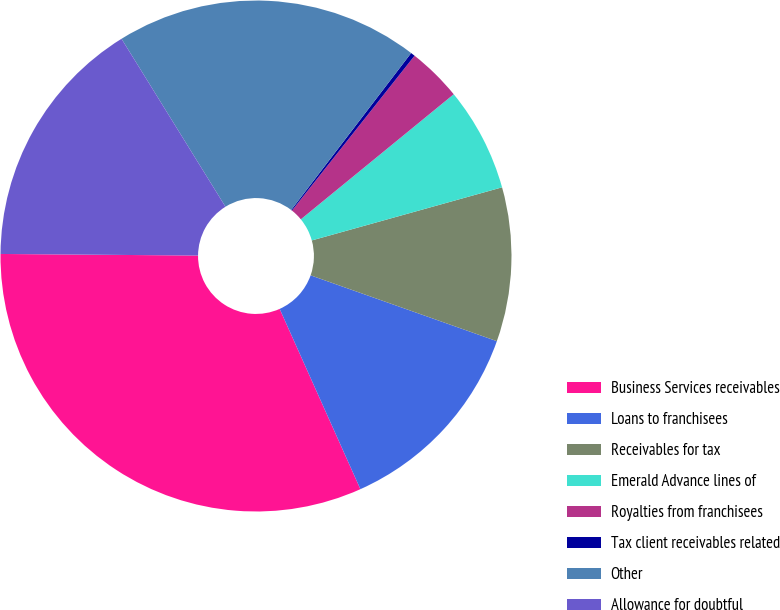Convert chart. <chart><loc_0><loc_0><loc_500><loc_500><pie_chart><fcel>Business Services receivables<fcel>Loans to franchisees<fcel>Receivables for tax<fcel>Emerald Advance lines of<fcel>Royalties from franchisees<fcel>Tax client receivables related<fcel>Other<fcel>Allowance for doubtful<nl><fcel>31.83%<fcel>12.89%<fcel>9.74%<fcel>6.58%<fcel>3.43%<fcel>0.27%<fcel>19.21%<fcel>16.05%<nl></chart> 